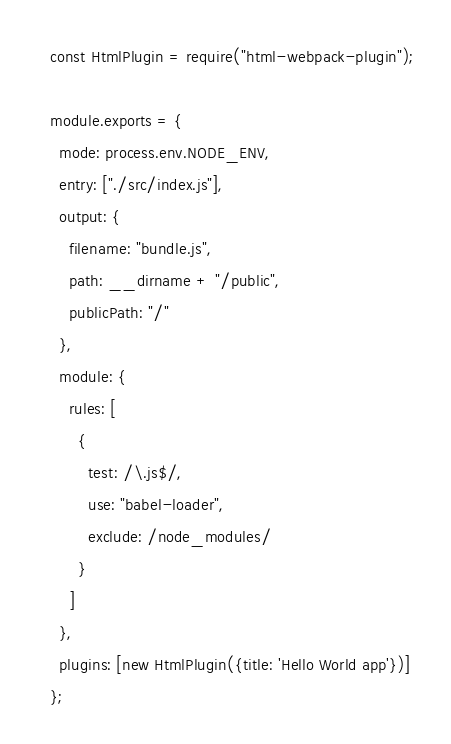Convert code to text. <code><loc_0><loc_0><loc_500><loc_500><_JavaScript_>const HtmlPlugin = require("html-webpack-plugin");

module.exports = {
  mode: process.env.NODE_ENV,
  entry: ["./src/index.js"],
  output: {
    filename: "bundle.js",
    path: __dirname + "/public",
    publicPath: "/"
  },
  module: {
    rules: [
      {
        test: /\.js$/,
        use: "babel-loader",
        exclude: /node_modules/
      }
    ]
  },
  plugins: [new HtmlPlugin({title: 'Hello World app'})]
};
</code> 